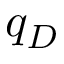<formula> <loc_0><loc_0><loc_500><loc_500>q _ { D }</formula> 